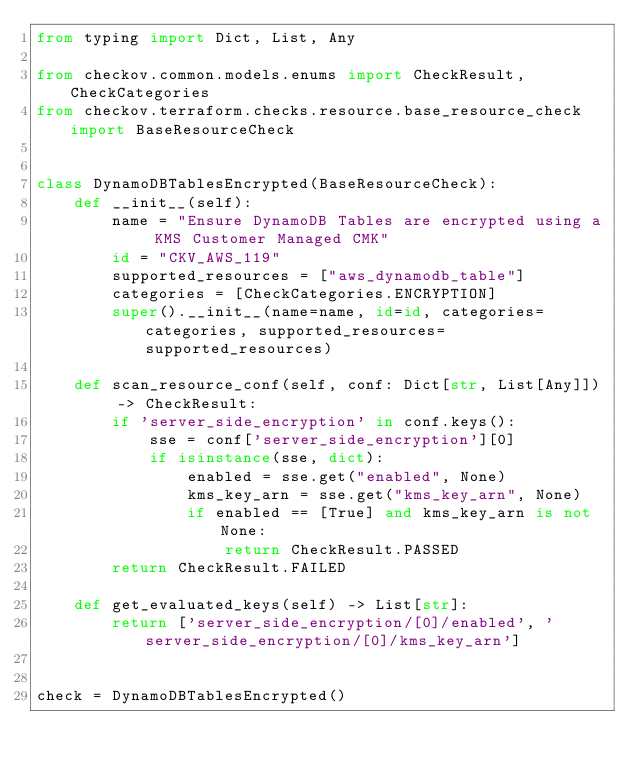Convert code to text. <code><loc_0><loc_0><loc_500><loc_500><_Python_>from typing import Dict, List, Any

from checkov.common.models.enums import CheckResult, CheckCategories
from checkov.terraform.checks.resource.base_resource_check import BaseResourceCheck


class DynamoDBTablesEncrypted(BaseResourceCheck):
    def __init__(self):
        name = "Ensure DynamoDB Tables are encrypted using a KMS Customer Managed CMK"
        id = "CKV_AWS_119"
        supported_resources = ["aws_dynamodb_table"]
        categories = [CheckCategories.ENCRYPTION]
        super().__init__(name=name, id=id, categories=categories, supported_resources=supported_resources)

    def scan_resource_conf(self, conf: Dict[str, List[Any]]) -> CheckResult:
        if 'server_side_encryption' in conf.keys():
            sse = conf['server_side_encryption'][0]
            if isinstance(sse, dict):
                enabled = sse.get("enabled", None)
                kms_key_arn = sse.get("kms_key_arn", None)
                if enabled == [True] and kms_key_arn is not None:
                    return CheckResult.PASSED
        return CheckResult.FAILED

    def get_evaluated_keys(self) -> List[str]:
        return ['server_side_encryption/[0]/enabled', 'server_side_encryption/[0]/kms_key_arn']


check = DynamoDBTablesEncrypted()
</code> 